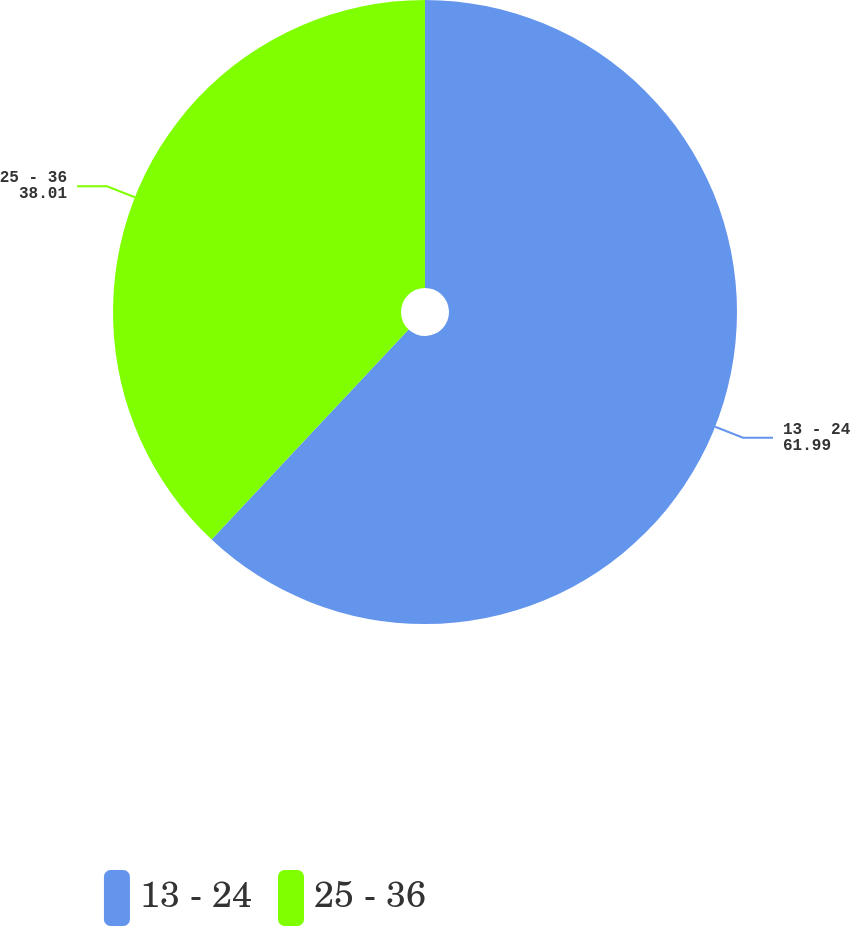Convert chart to OTSL. <chart><loc_0><loc_0><loc_500><loc_500><pie_chart><fcel>13 - 24<fcel>25 - 36<nl><fcel>61.99%<fcel>38.01%<nl></chart> 